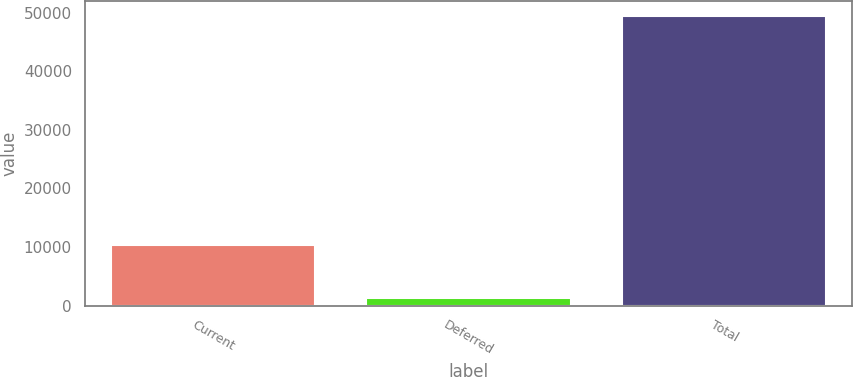<chart> <loc_0><loc_0><loc_500><loc_500><bar_chart><fcel>Current<fcel>Deferred<fcel>Total<nl><fcel>10323<fcel>1362<fcel>49511<nl></chart> 